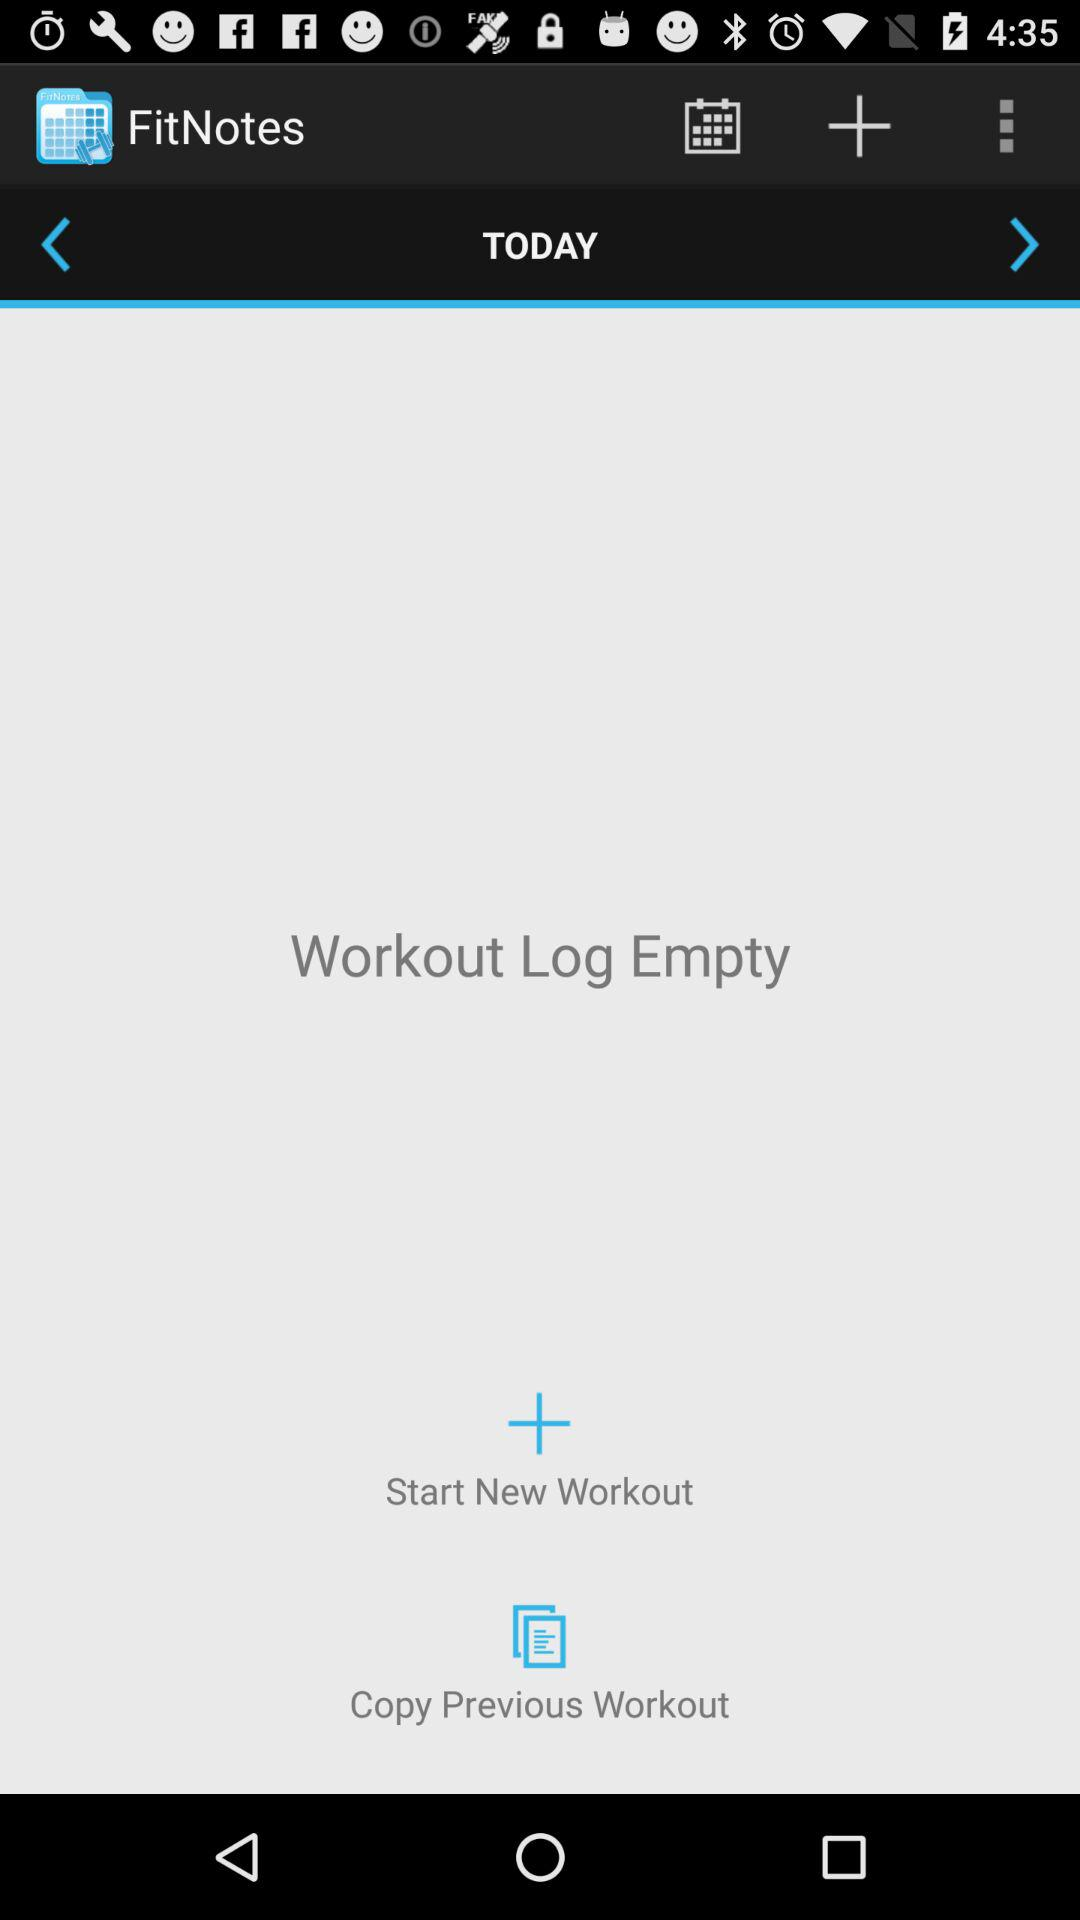What is the name of the application? The name of the application is "FitNotes". 